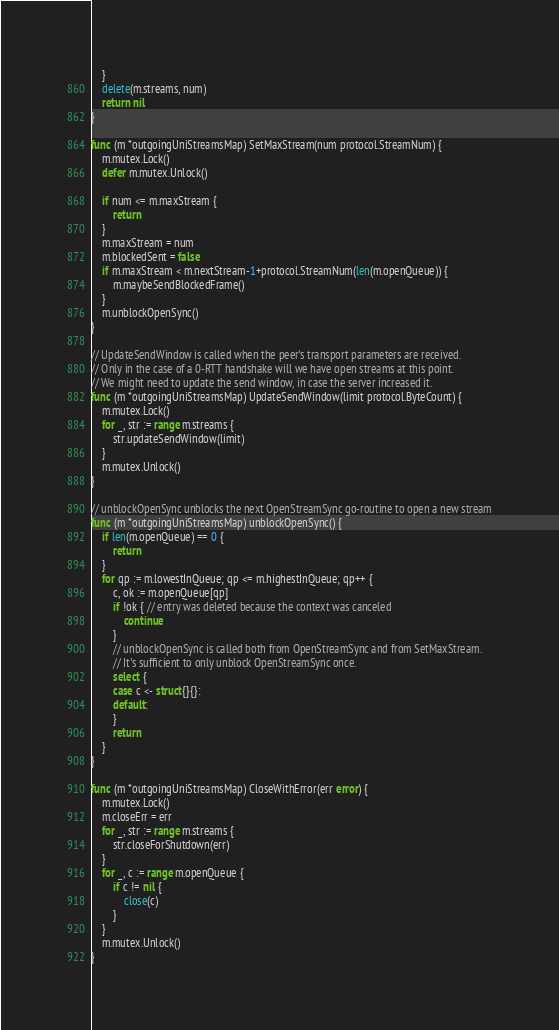<code> <loc_0><loc_0><loc_500><loc_500><_Go_>	}
	delete(m.streams, num)
	return nil
}

func (m *outgoingUniStreamsMap) SetMaxStream(num protocol.StreamNum) {
	m.mutex.Lock()
	defer m.mutex.Unlock()

	if num <= m.maxStream {
		return
	}
	m.maxStream = num
	m.blockedSent = false
	if m.maxStream < m.nextStream-1+protocol.StreamNum(len(m.openQueue)) {
		m.maybeSendBlockedFrame()
	}
	m.unblockOpenSync()
}

// UpdateSendWindow is called when the peer's transport parameters are received.
// Only in the case of a 0-RTT handshake will we have open streams at this point.
// We might need to update the send window, in case the server increased it.
func (m *outgoingUniStreamsMap) UpdateSendWindow(limit protocol.ByteCount) {
	m.mutex.Lock()
	for _, str := range m.streams {
		str.updateSendWindow(limit)
	}
	m.mutex.Unlock()
}

// unblockOpenSync unblocks the next OpenStreamSync go-routine to open a new stream
func (m *outgoingUniStreamsMap) unblockOpenSync() {
	if len(m.openQueue) == 0 {
		return
	}
	for qp := m.lowestInQueue; qp <= m.highestInQueue; qp++ {
		c, ok := m.openQueue[qp]
		if !ok { // entry was deleted because the context was canceled
			continue
		}
		// unblockOpenSync is called both from OpenStreamSync and from SetMaxStream.
		// It's sufficient to only unblock OpenStreamSync once.
		select {
		case c <- struct{}{}:
		default:
		}
		return
	}
}

func (m *outgoingUniStreamsMap) CloseWithError(err error) {
	m.mutex.Lock()
	m.closeErr = err
	for _, str := range m.streams {
		str.closeForShutdown(err)
	}
	for _, c := range m.openQueue {
		if c != nil {
			close(c)
		}
	}
	m.mutex.Unlock()
}
</code> 